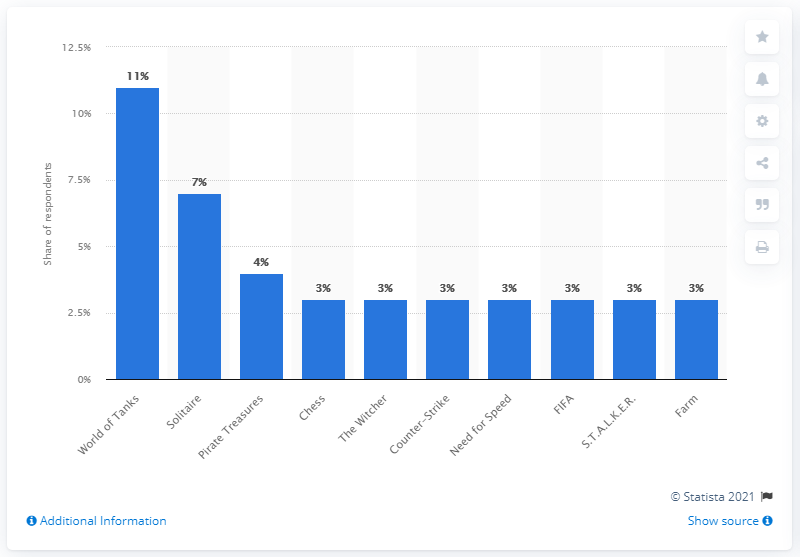Point out several critical features in this image. It is estimated that approximately 11% of Russian players supported Solitaire and Pirate Treasures. In 2019, a significant percentage of Russian players named World of Tanks as their favorite video game, with 11% of respondents indicating that it was their top choice. In 2019, World of Tanks was the most popular video game among Russian players. 